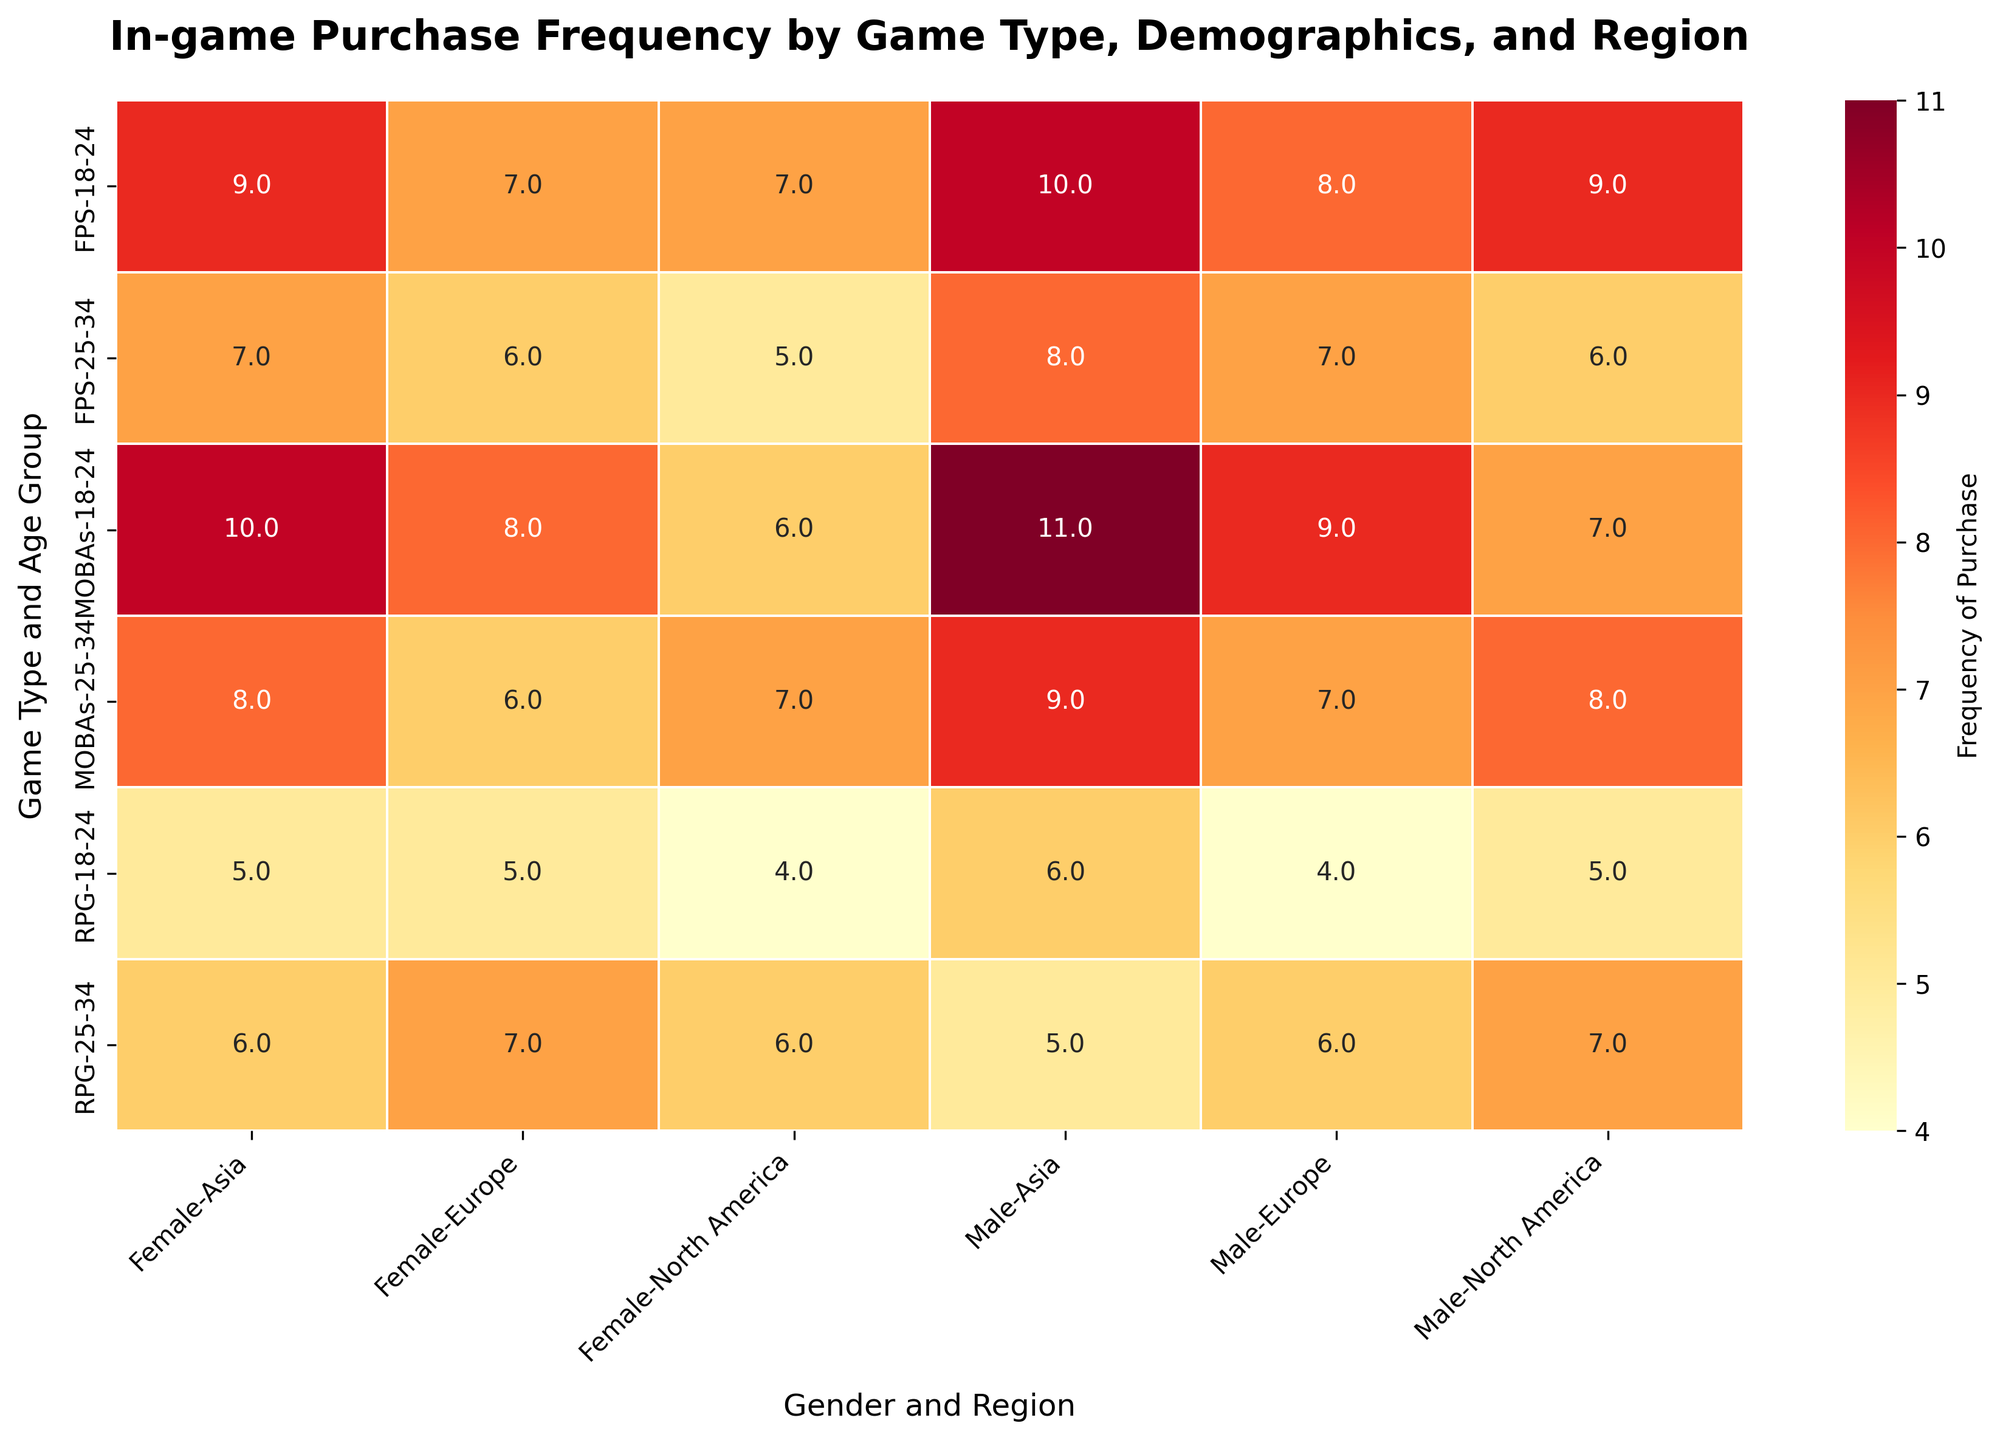What is the title of the heatmap? The title of the figure is usually found at the top of the heatmap and provides a succinct description of what the heatmap represents.
Answer: In-game Purchase Frequency by Game Type, Demographics, and Region What's the color range used in the heatmap? The color range is visually represented and is indicated by colors from light to dark, commonly seen in a color gradient at the side of the heatmap known as the color bar. In this heatmap, light colors usually represent lower frequencies of purchase, and dark colors represent higher frequencies.
Answer: Light yellow to dark red Which game type and player demographics have the highest frequency of purchase? To answer this, identify the darkest red cell on the heatmap, which indicates the highest frequency, then check the corresponding row and column labels to find the game type, age group, gender, and region.
Answer: MOBAs, 18-24, Male, Asia What's the average frequency of in-game purchases for RPG games in all age groups, genders, and regions? To find this, locate all the cells related to RPG games, sum their values, and divide by the number of those cells. The RPG-related cells are spread across multiple rows and columns.
Answer: 5.75 How does the frequency of in-game purchases for FPS games compare between North America and Asia for males aged 18-24? Locate the cells representing FPS, 18-24, Male for North America and Asia, then compare their values. Asia's higher purchase frequency can be seen from a darker red cell compared to North America.
Answer: Asia has a higher frequency For females aged 25-34, which region shows the highest frequency of purchases in MOBAs? Locate the row corresponding to MOBAs, 25-34, Female and compare the values across different regions (columns labeled with regions). The highest value will indicate the region with the highest frequency.
Answer: Asia Which age group in North America shows a higher frequency of in-game purchases for RPG games when comparing males? Compare the cells for RPG, North America, males between the 18-24 and 25-34 age groups.
Answer: 25-34 What is the difference in frequency of purchases for FPS games between males and females in Europe aged 25-34? Locate the cells for FPS, 25-34, Europe for both males and females, then subtract the value of females from the value of males.
Answer: 1 Among females in North America, how do RPG and MOBAs compare in terms of in-game purchase frequency for those aged 18-24? Compare the cells for RPG and MOBAs, North America, females, aged 18-24.
Answer: RPG is lower than MOBAs What is the median frequency of purchases for MOBAs across all age groups, genders, and regions? List all the values corresponding to MOBAs across the heatmap, sort them, and find the middle value. If there are an even number of values, take the average of the two middle values.
Answer: 8 